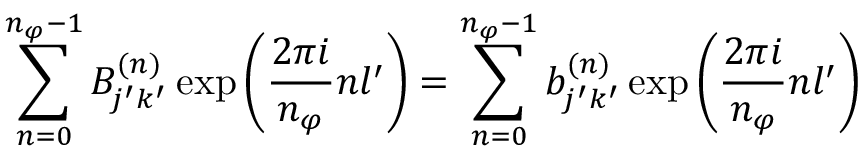Convert formula to latex. <formula><loc_0><loc_0><loc_500><loc_500>\sum _ { n = 0 } ^ { n _ { \varphi } - 1 } B _ { j ^ { \prime } k ^ { \prime } } ^ { ( n ) } \exp { \left ( \frac { 2 \pi i } { n _ { \varphi } } n l ^ { \prime } \right ) } = \sum _ { n = 0 } ^ { n _ { \varphi } - 1 } b _ { j ^ { \prime } k ^ { \prime } } ^ { ( n ) } \exp { \left ( \frac { 2 \pi i } { n _ { \varphi } } n l ^ { \prime } \right ) }</formula> 